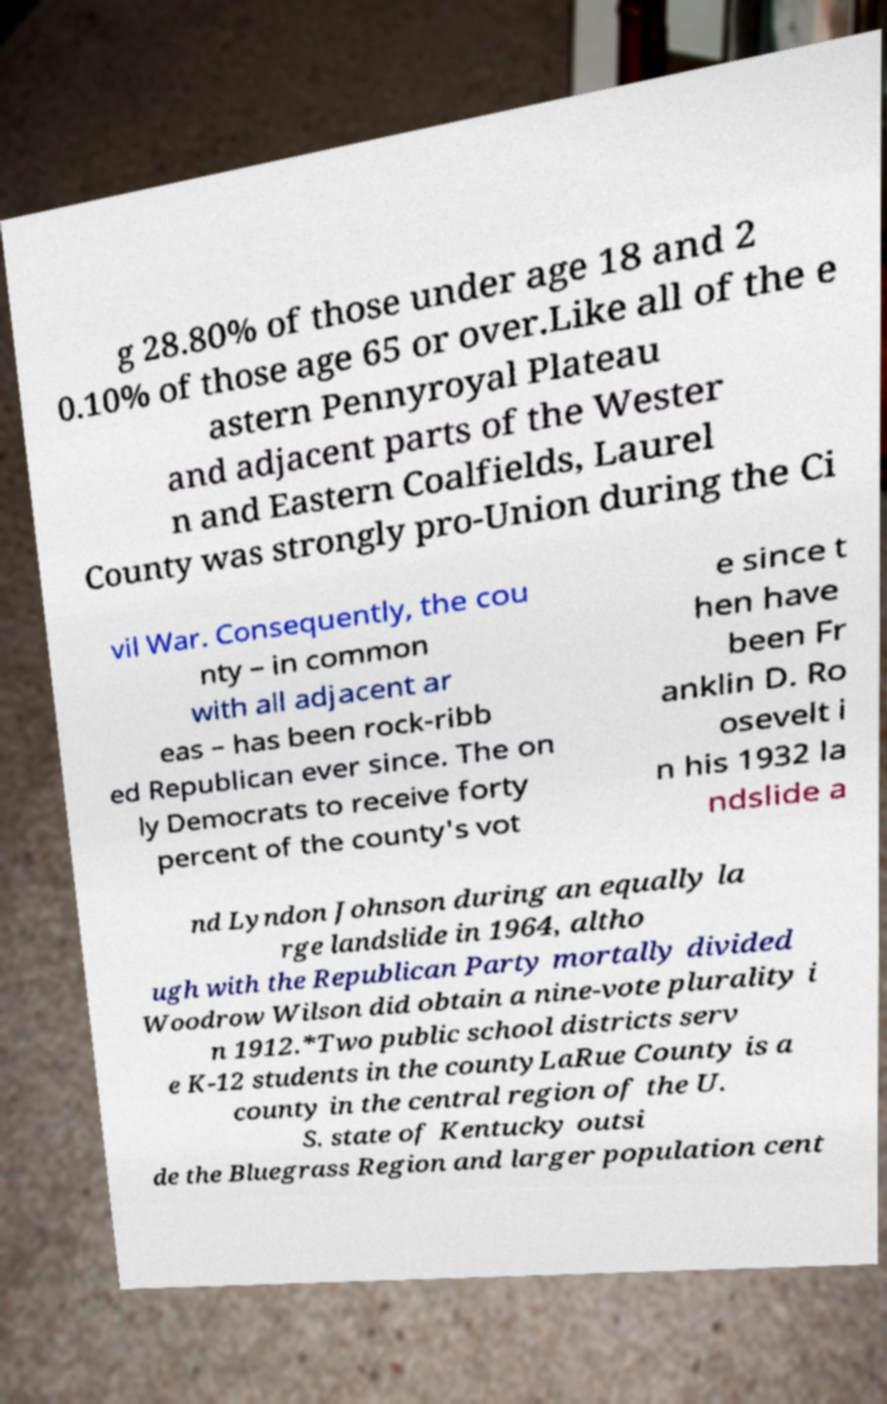What messages or text are displayed in this image? I need them in a readable, typed format. g 28.80% of those under age 18 and 2 0.10% of those age 65 or over.Like all of the e astern Pennyroyal Plateau and adjacent parts of the Wester n and Eastern Coalfields, Laurel County was strongly pro-Union during the Ci vil War. Consequently, the cou nty – in common with all adjacent ar eas – has been rock-ribb ed Republican ever since. The on ly Democrats to receive forty percent of the county's vot e since t hen have been Fr anklin D. Ro osevelt i n his 1932 la ndslide a nd Lyndon Johnson during an equally la rge landslide in 1964, altho ugh with the Republican Party mortally divided Woodrow Wilson did obtain a nine-vote plurality i n 1912.*Two public school districts serv e K-12 students in the countyLaRue County is a county in the central region of the U. S. state of Kentucky outsi de the Bluegrass Region and larger population cent 